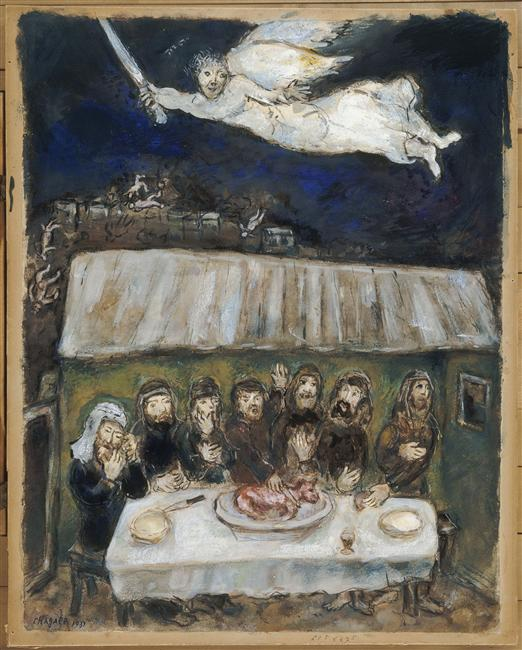Can you explain the symbolism behind the angel-like figure with a sword? The angel-like figure with a sword in the image likely symbolizes divine intervention or protection. Angels are often depicted as messengers of important news or protectors in various cultural and religious contexts. The sword could represent justice, power, or a specific decree being executed by a higher power, adding layers of meaning to the scene below. 